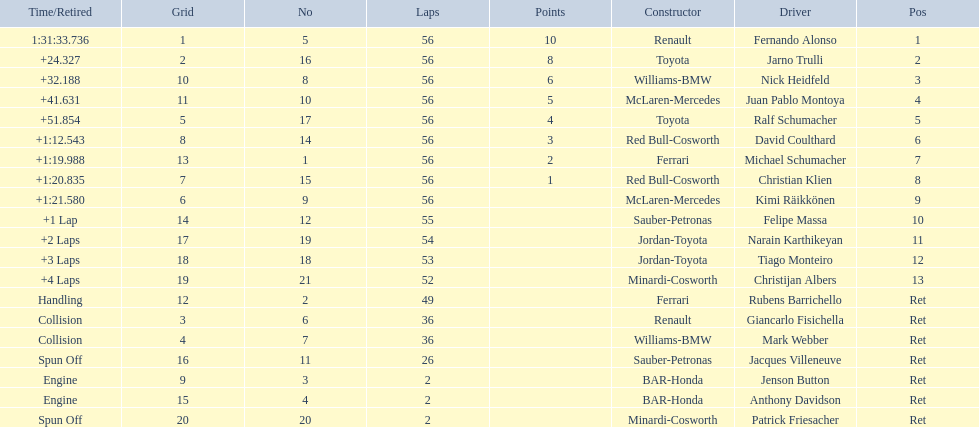Who raced during the 2005 malaysian grand prix? Fernando Alonso, Jarno Trulli, Nick Heidfeld, Juan Pablo Montoya, Ralf Schumacher, David Coulthard, Michael Schumacher, Christian Klien, Kimi Räikkönen, Felipe Massa, Narain Karthikeyan, Tiago Monteiro, Christijan Albers, Rubens Barrichello, Giancarlo Fisichella, Mark Webber, Jacques Villeneuve, Jenson Button, Anthony Davidson, Patrick Friesacher. What were their finishing times? 1:31:33.736, +24.327, +32.188, +41.631, +51.854, +1:12.543, +1:19.988, +1:20.835, +1:21.580, +1 Lap, +2 Laps, +3 Laps, +4 Laps, Handling, Collision, Collision, Spun Off, Engine, Engine, Spun Off. What was fernando alonso's finishing time? 1:31:33.736. 